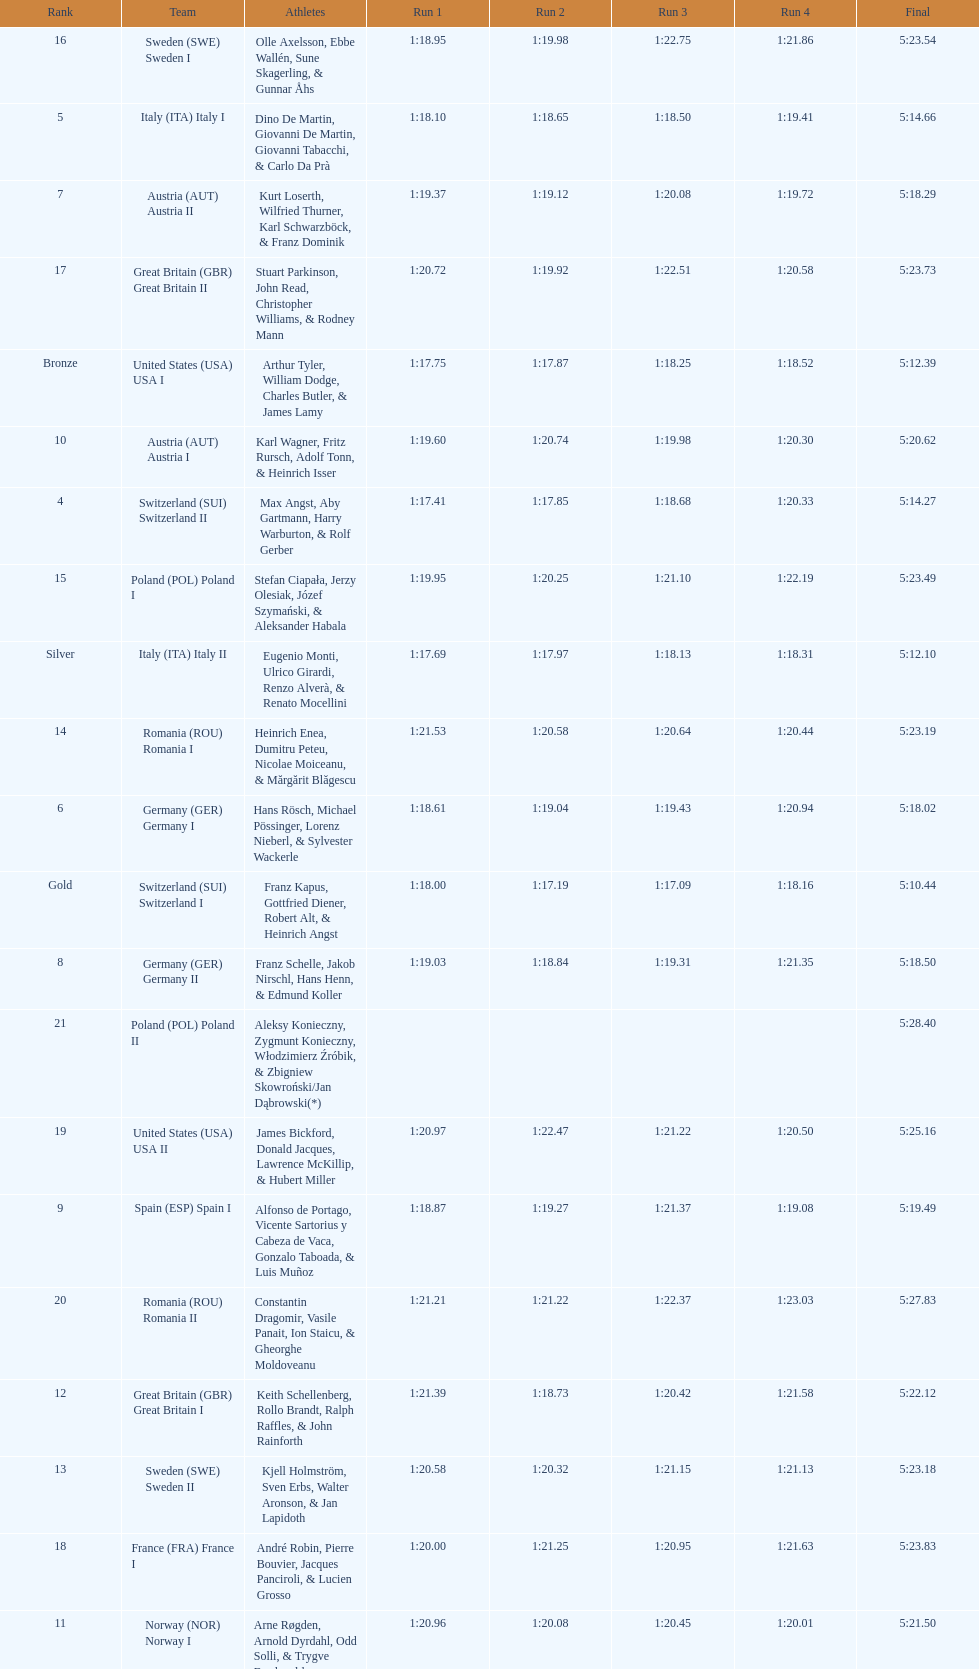Who placed the highest, italy or germany? Italy. 